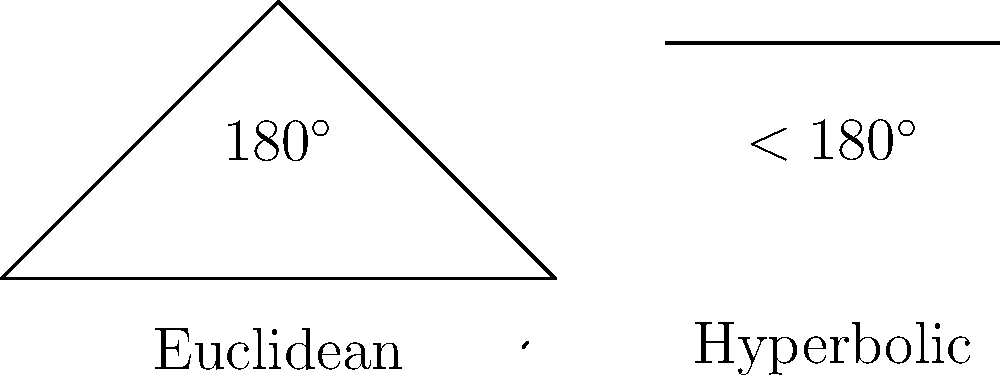In the context of workplace diversity training, understanding different perspectives is crucial. The image above illustrates triangle sum theorems in three geometries. How might these geometries serve as a metaphor for diverse cultural perspectives in a multicultural workplace, and which geometry best represents a workplace where cultural differences are viewed as additive rather than conflicting? To answer this question, let's analyze each geometry and its potential metaphorical significance in a multicultural workplace:

1. Euclidean Geometry:
   - Triangle sum is always 180°
   - Metaphor: Represents a standardized, one-size-fits-all approach to workplace culture
   - In diversity context: May symbolize a workplace that expects all cultures to conform to a single norm

2. Hyperbolic Geometry:
   - Triangle sum is less than 180°
   - Metaphor: Represents a workplace where cultural differences are seen as conflicting or reducing overall harmony
   - In diversity context: May symbolize a workplace where diverse perspectives are viewed as challenges to overcome

3. Spherical Geometry:
   - Triangle sum is greater than 180°
   - Metaphor: Represents a workplace where cultural differences add value and expand perspectives
   - In diversity context: Symbolizes a workplace where diverse viewpoints are seen as additive, enriching the overall work environment

The spherical geometry best represents a workplace where cultural differences are viewed as additive rather than conflicting. In spherical geometry, the sum of angles in a triangle is always greater than 180°, which can be interpreted as each unique perspective contributing additional value to the workplace, expanding the overall understanding and capability of the team.

This metaphor aligns with the concept of cultural synergy in sociology, where the interaction of different cultures produces a combined effect greater than the sum of their separate effects. It encourages viewing diversity as a strength that enhances creativity, problem-solving, and innovation in the workplace.
Answer: Spherical geometry, as it represents cultural differences as additive and enriching. 